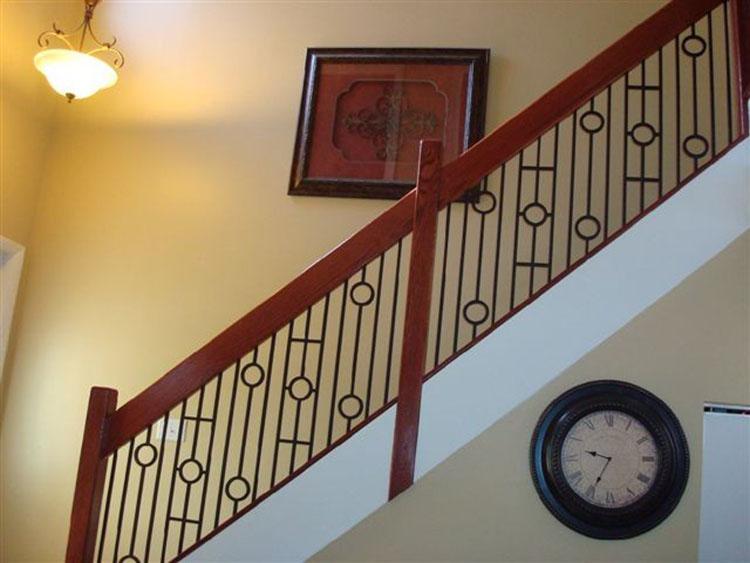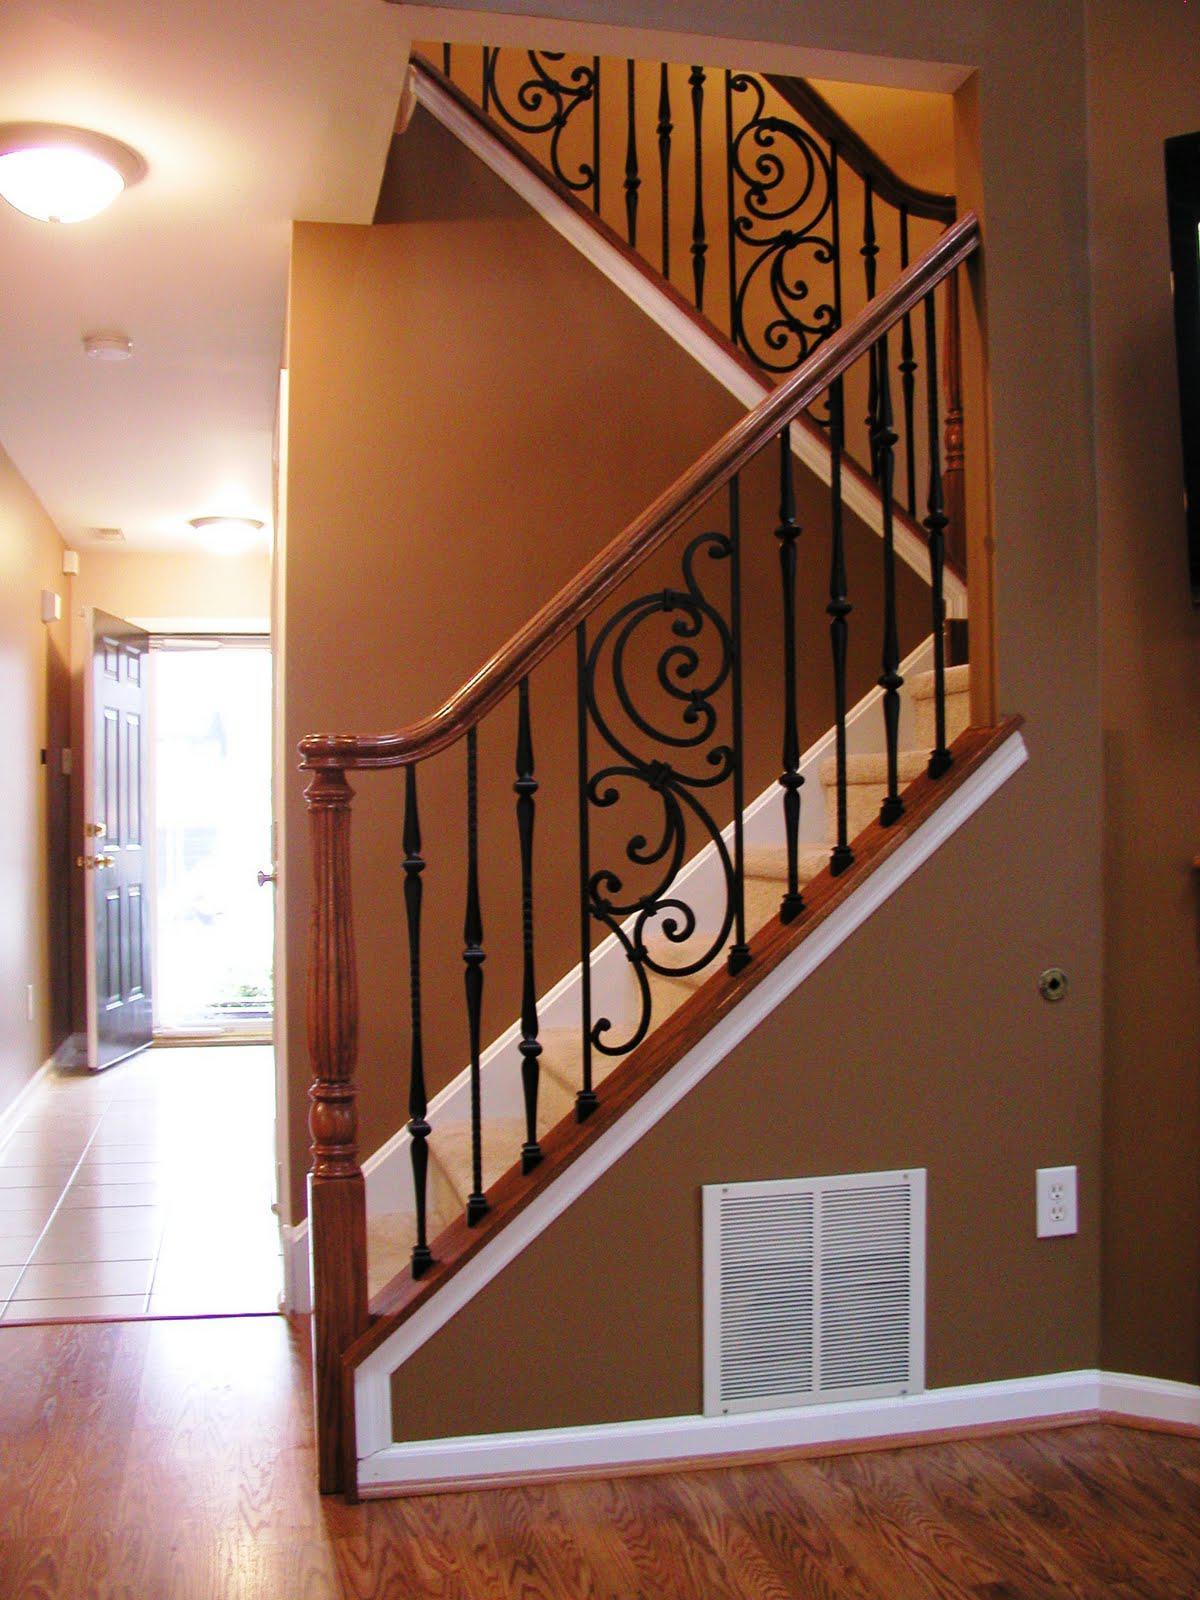The first image is the image on the left, the second image is the image on the right. Examine the images to the left and right. Is the description "In at least one image there is a framed brown piece of artwork hung over stairs with metal rods that have circles in them." accurate? Answer yes or no. Yes. The first image is the image on the left, the second image is the image on the right. Evaluate the accuracy of this statement regarding the images: "The stairway in the right image goes straight.". Is it true? Answer yes or no. No. 